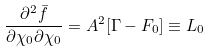Convert formula to latex. <formula><loc_0><loc_0><loc_500><loc_500>\frac { \partial ^ { 2 } \bar { f } } { \partial \chi _ { 0 } \partial \chi _ { 0 } } = A ^ { 2 } [ \Gamma - F _ { 0 } ] \equiv L _ { 0 }</formula> 